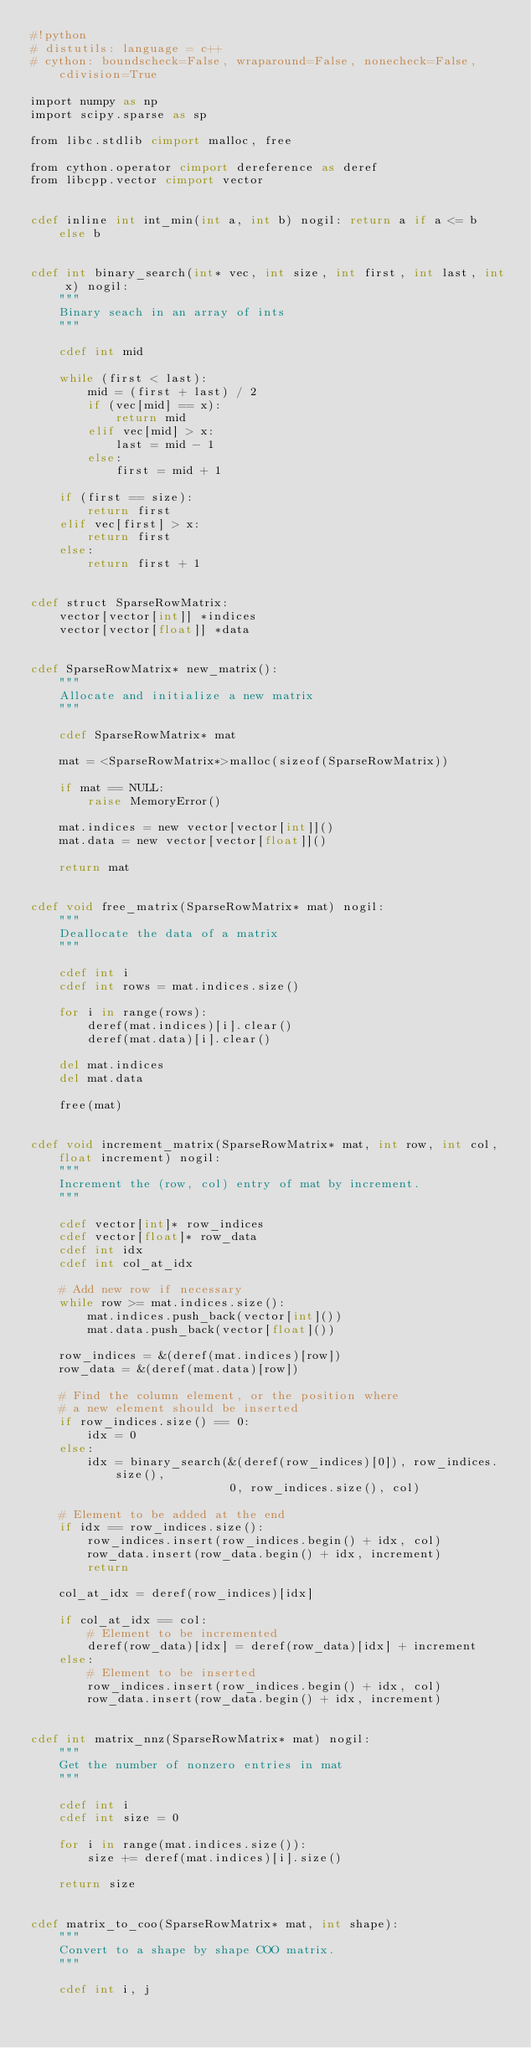Convert code to text. <code><loc_0><loc_0><loc_500><loc_500><_Cython_>#!python
# distutils: language = c++
# cython: boundscheck=False, wraparound=False, nonecheck=False, cdivision=True

import numpy as np
import scipy.sparse as sp

from libc.stdlib cimport malloc, free

from cython.operator cimport dereference as deref
from libcpp.vector cimport vector


cdef inline int int_min(int a, int b) nogil: return a if a <= b else b


cdef int binary_search(int* vec, int size, int first, int last, int x) nogil:
    """
    Binary seach in an array of ints
    """

    cdef int mid

    while (first < last):
        mid = (first + last) / 2
        if (vec[mid] == x):
            return mid
        elif vec[mid] > x:
            last = mid - 1
        else:
            first = mid + 1

    if (first == size):
        return first
    elif vec[first] > x:
        return first
    else:
        return first + 1


cdef struct SparseRowMatrix:
    vector[vector[int]] *indices
    vector[vector[float]] *data


cdef SparseRowMatrix* new_matrix():
    """
    Allocate and initialize a new matrix
    """

    cdef SparseRowMatrix* mat

    mat = <SparseRowMatrix*>malloc(sizeof(SparseRowMatrix))

    if mat == NULL:
        raise MemoryError()

    mat.indices = new vector[vector[int]]()
    mat.data = new vector[vector[float]]()

    return mat


cdef void free_matrix(SparseRowMatrix* mat) nogil:
    """
    Deallocate the data of a matrix
    """

    cdef int i
    cdef int rows = mat.indices.size()

    for i in range(rows):
        deref(mat.indices)[i].clear()
        deref(mat.data)[i].clear()

    del mat.indices
    del mat.data

    free(mat)


cdef void increment_matrix(SparseRowMatrix* mat, int row, int col, float increment) nogil:
    """
    Increment the (row, col) entry of mat by increment.
    """

    cdef vector[int]* row_indices
    cdef vector[float]* row_data
    cdef int idx
    cdef int col_at_idx

    # Add new row if necessary
    while row >= mat.indices.size():
        mat.indices.push_back(vector[int]())
        mat.data.push_back(vector[float]())

    row_indices = &(deref(mat.indices)[row])
    row_data = &(deref(mat.data)[row])

    # Find the column element, or the position where
    # a new element should be inserted
    if row_indices.size() == 0:
        idx = 0
    else:
        idx = binary_search(&(deref(row_indices)[0]), row_indices.size(),
                            0, row_indices.size(), col)

    # Element to be added at the end
    if idx == row_indices.size():
        row_indices.insert(row_indices.begin() + idx, col)
        row_data.insert(row_data.begin() + idx, increment)
        return

    col_at_idx = deref(row_indices)[idx]

    if col_at_idx == col:
        # Element to be incremented
        deref(row_data)[idx] = deref(row_data)[idx] + increment
    else:
        # Element to be inserted
        row_indices.insert(row_indices.begin() + idx, col)
        row_data.insert(row_data.begin() + idx, increment)


cdef int matrix_nnz(SparseRowMatrix* mat) nogil:
    """
    Get the number of nonzero entries in mat
    """

    cdef int i
    cdef int size = 0

    for i in range(mat.indices.size()):
        size += deref(mat.indices)[i].size()

    return size


cdef matrix_to_coo(SparseRowMatrix* mat, int shape):
    """
    Convert to a shape by shape COO matrix.
    """

    cdef int i, j</code> 